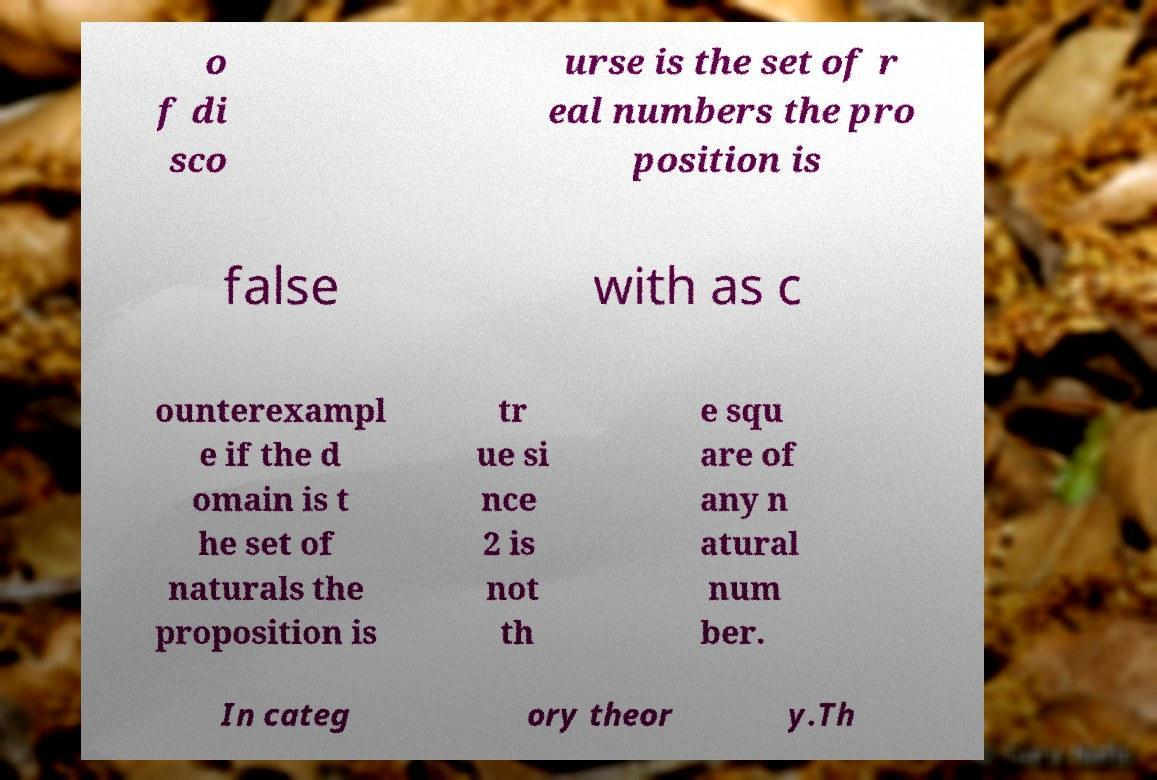Please identify and transcribe the text found in this image. o f di sco urse is the set of r eal numbers the pro position is false with as c ounterexampl e if the d omain is t he set of naturals the proposition is tr ue si nce 2 is not th e squ are of any n atural num ber. In categ ory theor y.Th 